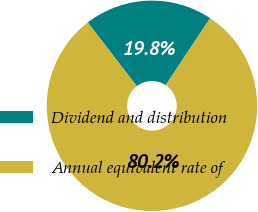<chart> <loc_0><loc_0><loc_500><loc_500><pie_chart><fcel>Dividend and distribution<fcel>Annual equivalent rate of<nl><fcel>19.77%<fcel>80.23%<nl></chart> 